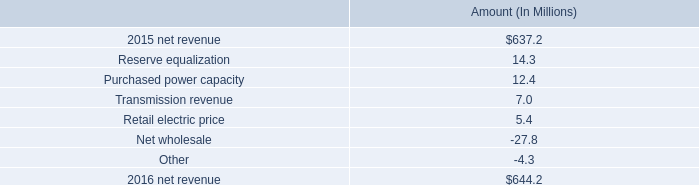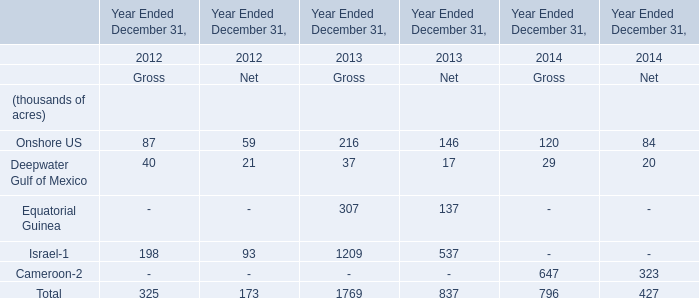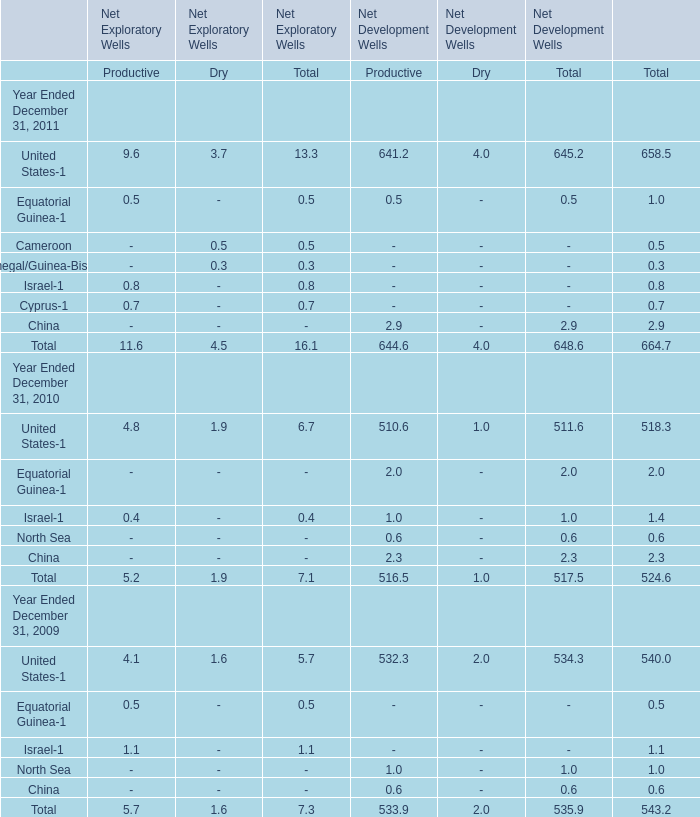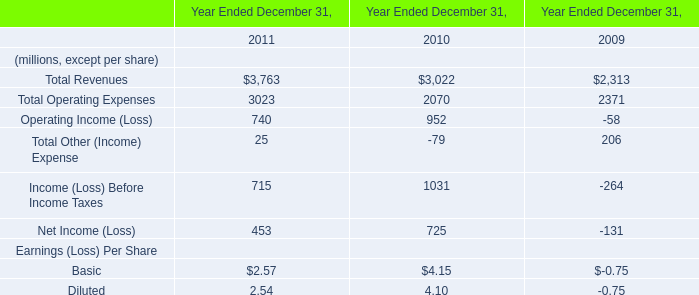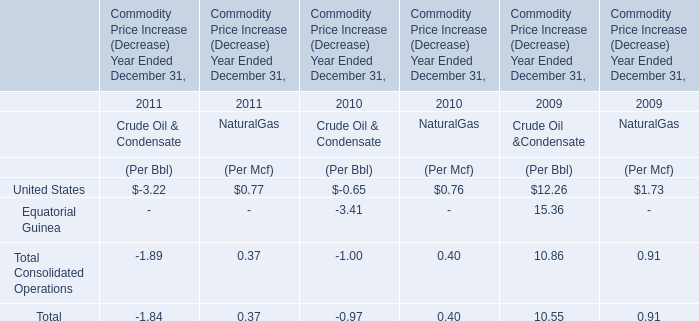Which year is United States-1 for Total the least? 
Answer: 2010. 